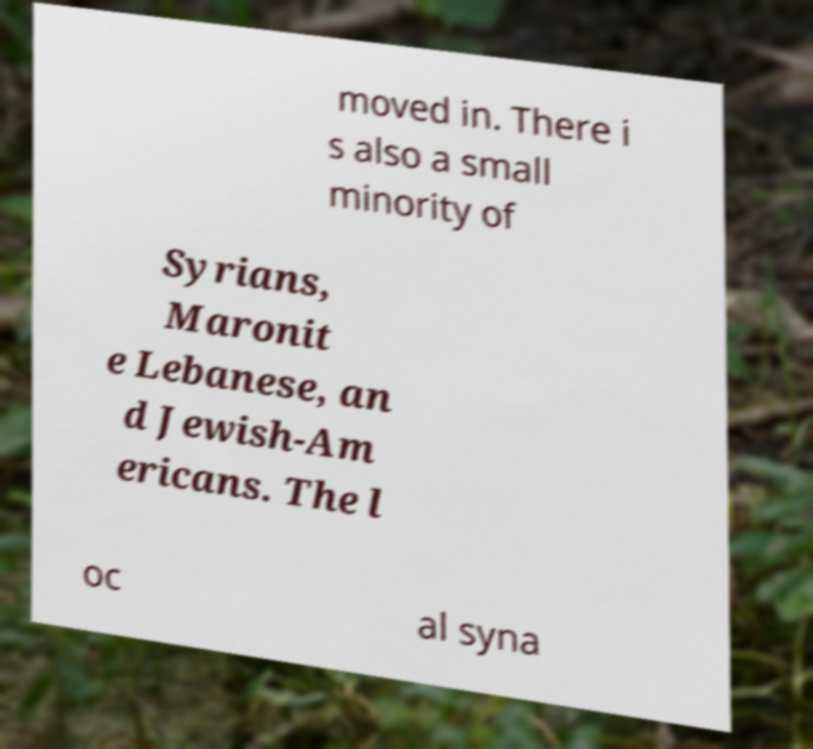Please read and relay the text visible in this image. What does it say? moved in. There i s also a small minority of Syrians, Maronit e Lebanese, an d Jewish-Am ericans. The l oc al syna 